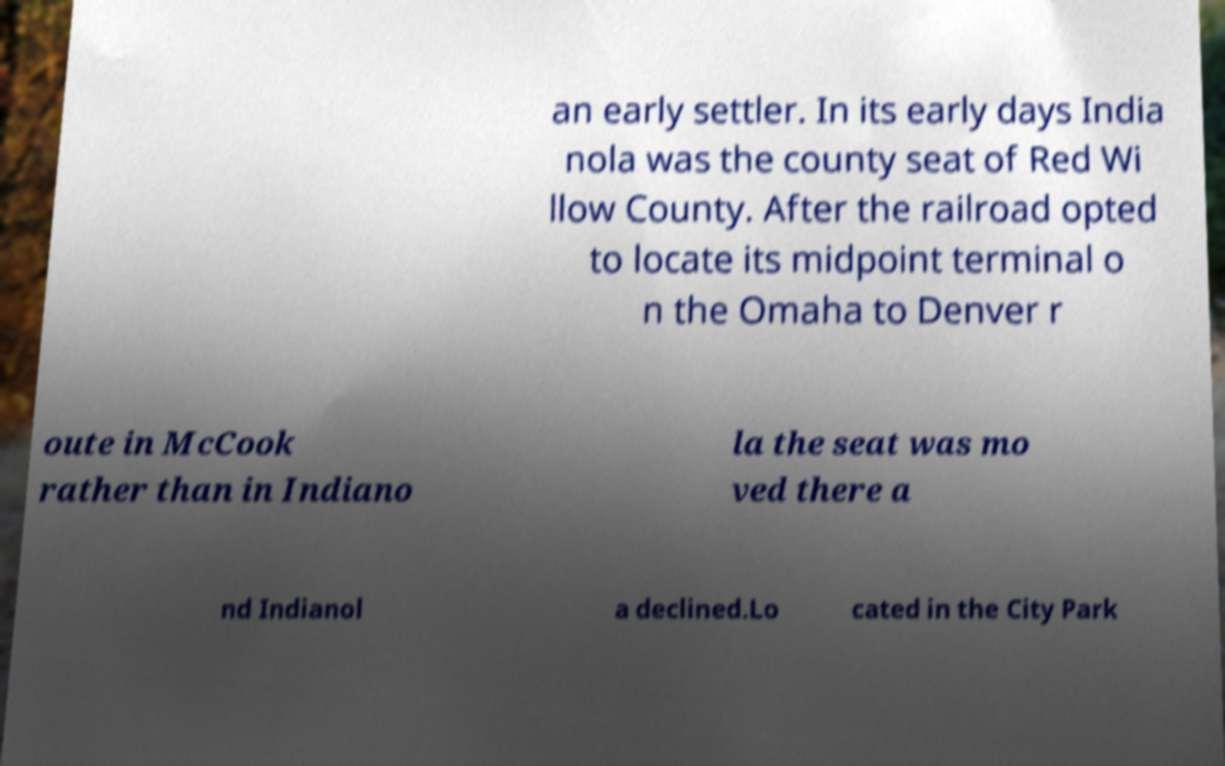Can you read and provide the text displayed in the image?This photo seems to have some interesting text. Can you extract and type it out for me? an early settler. In its early days India nola was the county seat of Red Wi llow County. After the railroad opted to locate its midpoint terminal o n the Omaha to Denver r oute in McCook rather than in Indiano la the seat was mo ved there a nd Indianol a declined.Lo cated in the City Park 